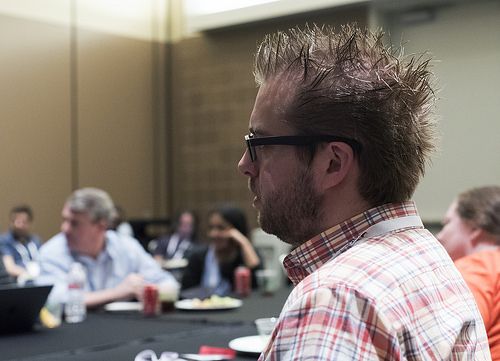<image>
Is there a man behind the coke? No. The man is not behind the coke. From this viewpoint, the man appears to be positioned elsewhere in the scene. 